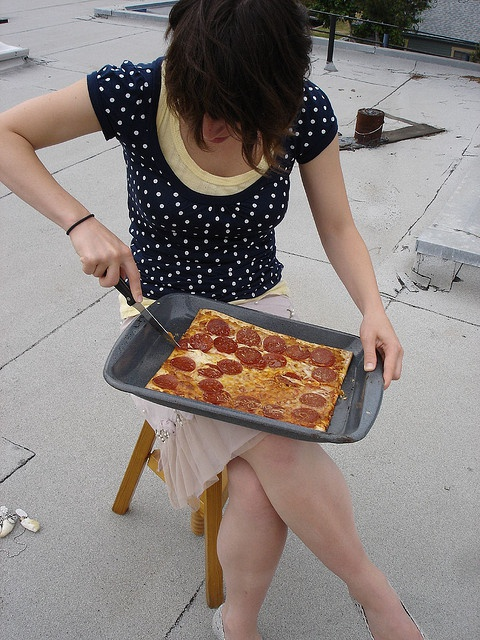Describe the objects in this image and their specific colors. I can see people in darkgray, black, and tan tones, pizza in darkgray, brown, maroon, and tan tones, chair in darkgray, maroon, and olive tones, and knife in darkgray, black, and gray tones in this image. 